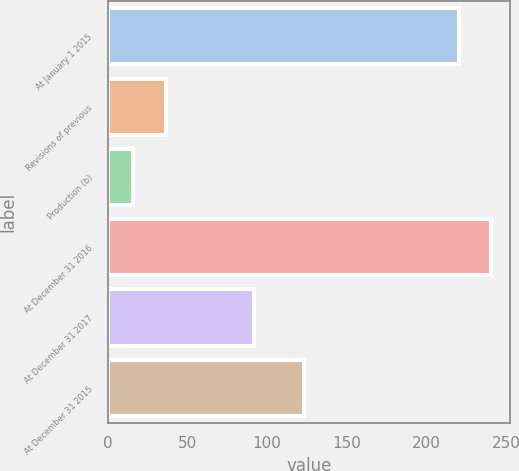Convert chart. <chart><loc_0><loc_0><loc_500><loc_500><bar_chart><fcel>At January 1 2015<fcel>Revisions of previous<fcel>Production (b)<fcel>At December 31 2016<fcel>At December 31 2017<fcel>At December 31 2015<nl><fcel>220<fcel>36.4<fcel>16<fcel>240.4<fcel>92<fcel>123<nl></chart> 